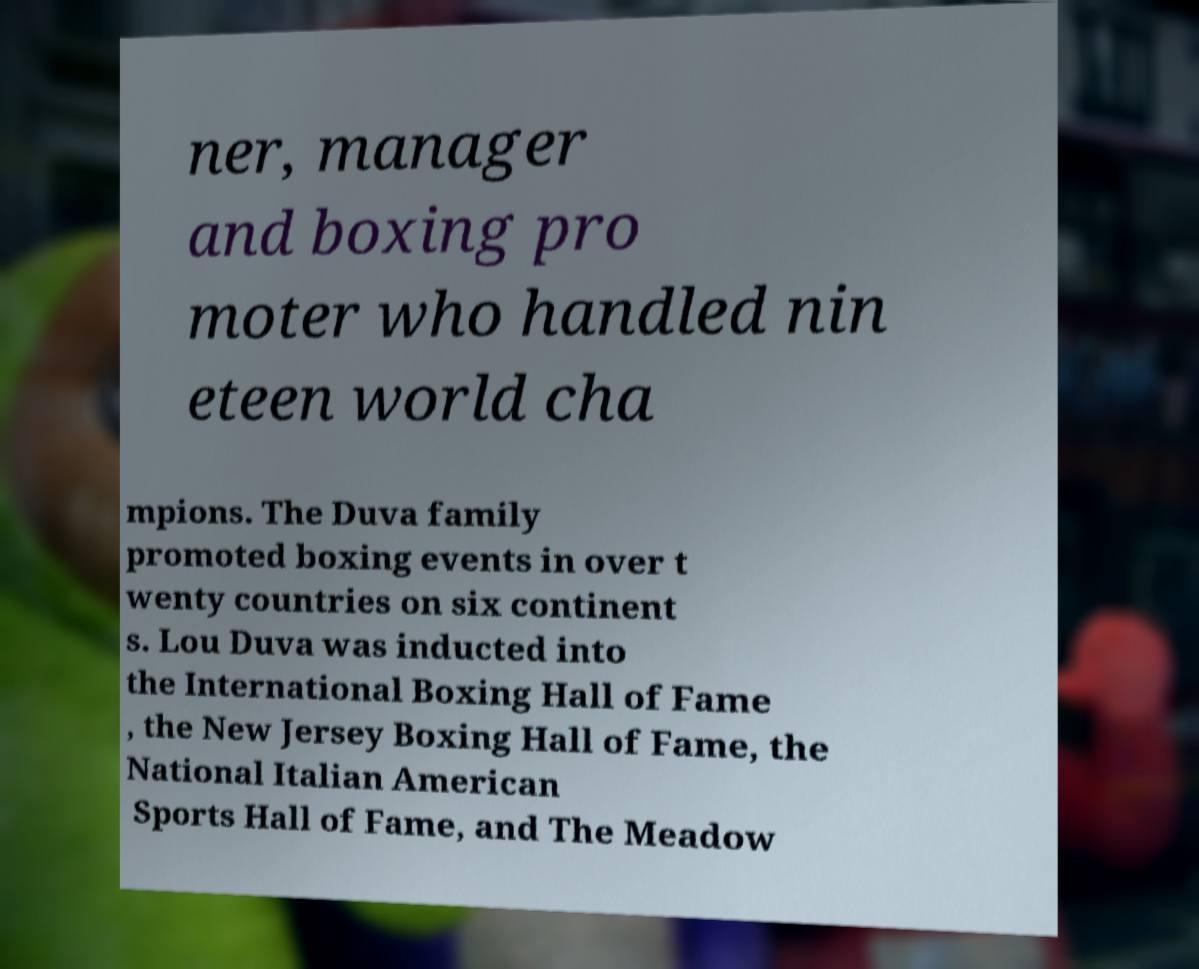Please identify and transcribe the text found in this image. ner, manager and boxing pro moter who handled nin eteen world cha mpions. The Duva family promoted boxing events in over t wenty countries on six continent s. Lou Duva was inducted into the International Boxing Hall of Fame , the New Jersey Boxing Hall of Fame, the National Italian American Sports Hall of Fame, and The Meadow 